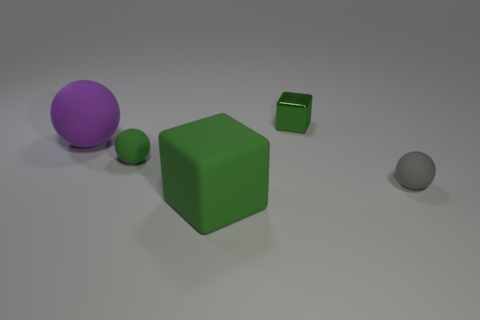Add 3 big green rubber objects. How many objects exist? 8 Subtract all spheres. How many objects are left? 2 Subtract 2 green blocks. How many objects are left? 3 Subtract all large green blocks. Subtract all small blue metallic blocks. How many objects are left? 4 Add 5 tiny gray spheres. How many tiny gray spheres are left? 6 Add 3 tiny cyan rubber balls. How many tiny cyan rubber balls exist? 3 